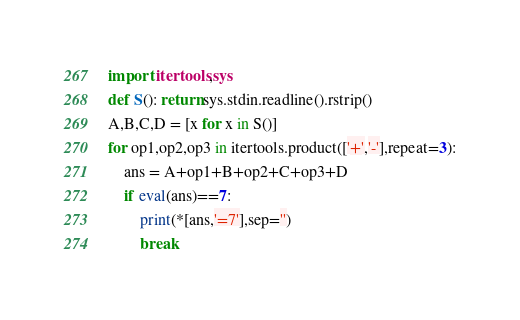Convert code to text. <code><loc_0><loc_0><loc_500><loc_500><_Python_>import itertools,sys
def S(): return sys.stdin.readline().rstrip()
A,B,C,D = [x for x in S()]
for op1,op2,op3 in itertools.product(['+','-'],repeat=3):
    ans = A+op1+B+op2+C+op3+D
    if eval(ans)==7:
        print(*[ans,'=7'],sep='')
        break
</code> 